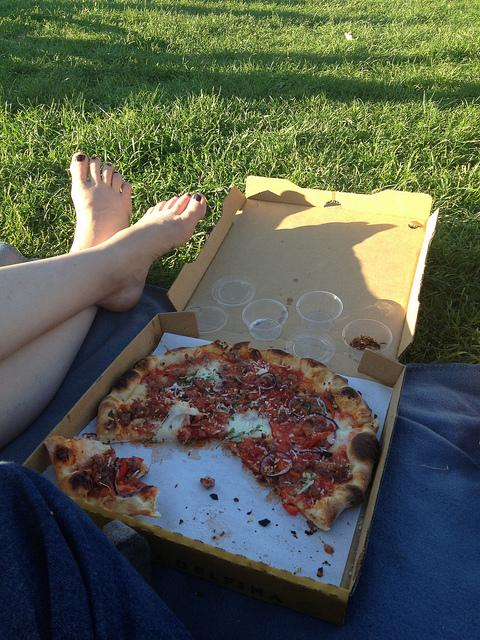What is the proper name for this style of eating? Please explain your reasoning. picnic. They are on a blanket in some grass outside 